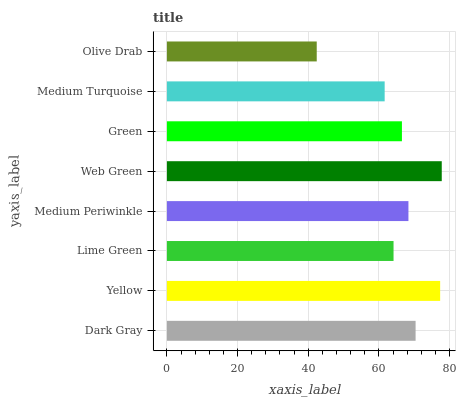Is Olive Drab the minimum?
Answer yes or no. Yes. Is Web Green the maximum?
Answer yes or no. Yes. Is Yellow the minimum?
Answer yes or no. No. Is Yellow the maximum?
Answer yes or no. No. Is Yellow greater than Dark Gray?
Answer yes or no. Yes. Is Dark Gray less than Yellow?
Answer yes or no. Yes. Is Dark Gray greater than Yellow?
Answer yes or no. No. Is Yellow less than Dark Gray?
Answer yes or no. No. Is Medium Periwinkle the high median?
Answer yes or no. Yes. Is Green the low median?
Answer yes or no. Yes. Is Medium Turquoise the high median?
Answer yes or no. No. Is Dark Gray the low median?
Answer yes or no. No. 